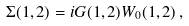<formula> <loc_0><loc_0><loc_500><loc_500>\Sigma ( 1 , 2 ) = i G ( 1 , 2 ) W _ { 0 } ( 1 , 2 ) \, ,</formula> 